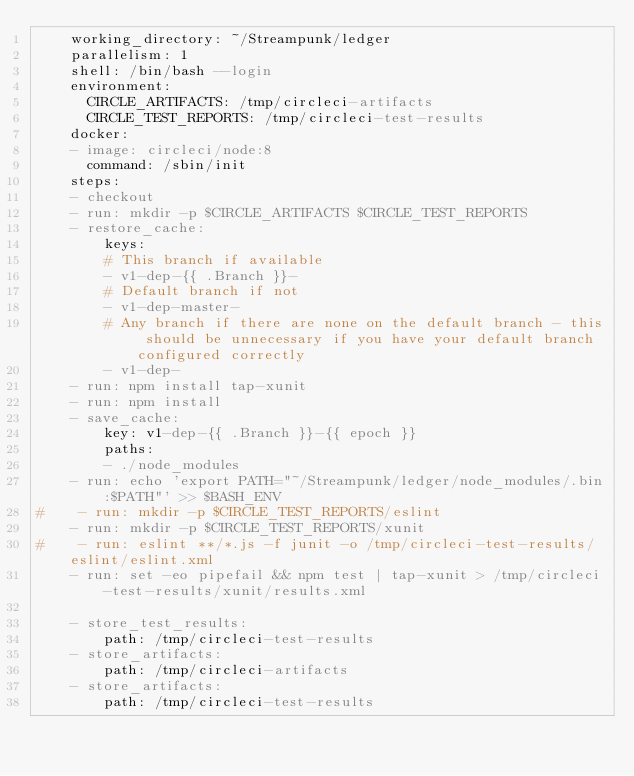<code> <loc_0><loc_0><loc_500><loc_500><_YAML_>    working_directory: ~/Streampunk/ledger
    parallelism: 1
    shell: /bin/bash --login
    environment:
      CIRCLE_ARTIFACTS: /tmp/circleci-artifacts
      CIRCLE_TEST_REPORTS: /tmp/circleci-test-results
    docker:
    - image: circleci/node:8
      command: /sbin/init
    steps:
    - checkout
    - run: mkdir -p $CIRCLE_ARTIFACTS $CIRCLE_TEST_REPORTS
    - restore_cache:
        keys:
        # This branch if available
        - v1-dep-{{ .Branch }}-
        # Default branch if not
        - v1-dep-master-
        # Any branch if there are none on the default branch - this should be unnecessary if you have your default branch configured correctly
        - v1-dep-
    - run: npm install tap-xunit
    - run: npm install
    - save_cache:
        key: v1-dep-{{ .Branch }}-{{ epoch }}
        paths:
        - ./node_modules
    - run: echo 'export PATH="~/Streampunk/ledger/node_modules/.bin:$PATH"' >> $BASH_ENV
#    - run: mkdir -p $CIRCLE_TEST_REPORTS/eslint
    - run: mkdir -p $CIRCLE_TEST_REPORTS/xunit
#    - run: eslint **/*.js -f junit -o /tmp/circleci-test-results/eslint/eslint.xml
    - run: set -eo pipefail && npm test | tap-xunit > /tmp/circleci-test-results/xunit/results.xml
      
    - store_test_results:
        path: /tmp/circleci-test-results
    - store_artifacts:
        path: /tmp/circleci-artifacts
    - store_artifacts:
        path: /tmp/circleci-test-results
</code> 